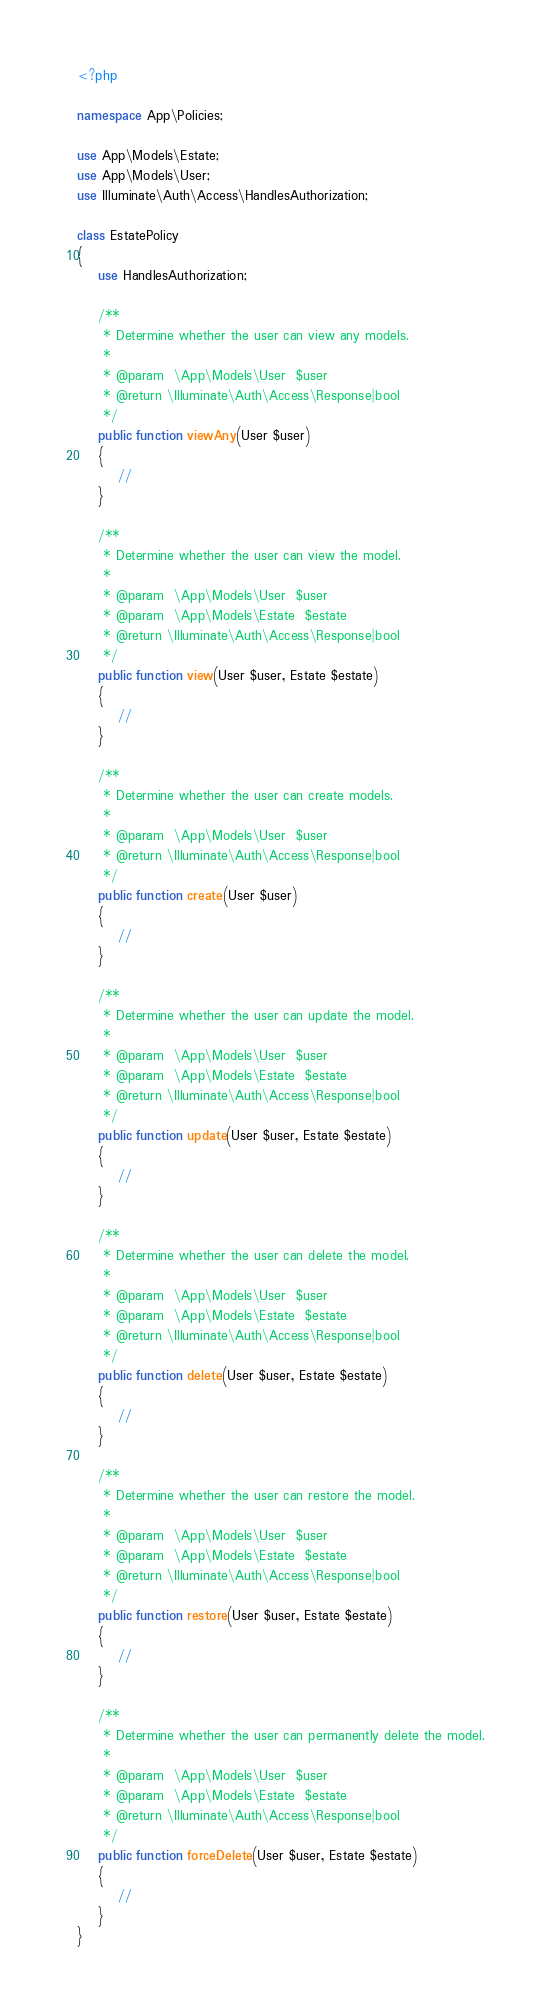<code> <loc_0><loc_0><loc_500><loc_500><_PHP_><?php

namespace App\Policies;

use App\Models\Estate;
use App\Models\User;
use Illuminate\Auth\Access\HandlesAuthorization;

class EstatePolicy
{
    use HandlesAuthorization;

    /**
     * Determine whether the user can view any models.
     *
     * @param  \App\Models\User  $user
     * @return \Illuminate\Auth\Access\Response|bool
     */
    public function viewAny(User $user)
    {
        //
    }

    /**
     * Determine whether the user can view the model.
     *
     * @param  \App\Models\User  $user
     * @param  \App\Models\Estate  $estate
     * @return \Illuminate\Auth\Access\Response|bool
     */
    public function view(User $user, Estate $estate)
    {
        //
    }

    /**
     * Determine whether the user can create models.
     *
     * @param  \App\Models\User  $user
     * @return \Illuminate\Auth\Access\Response|bool
     */
    public function create(User $user)
    {
        //
    }

    /**
     * Determine whether the user can update the model.
     *
     * @param  \App\Models\User  $user
     * @param  \App\Models\Estate  $estate
     * @return \Illuminate\Auth\Access\Response|bool
     */
    public function update(User $user, Estate $estate)
    {
        //
    }

    /**
     * Determine whether the user can delete the model.
     *
     * @param  \App\Models\User  $user
     * @param  \App\Models\Estate  $estate
     * @return \Illuminate\Auth\Access\Response|bool
     */
    public function delete(User $user, Estate $estate)
    {
        //
    }

    /**
     * Determine whether the user can restore the model.
     *
     * @param  \App\Models\User  $user
     * @param  \App\Models\Estate  $estate
     * @return \Illuminate\Auth\Access\Response|bool
     */
    public function restore(User $user, Estate $estate)
    {
        //
    }

    /**
     * Determine whether the user can permanently delete the model.
     *
     * @param  \App\Models\User  $user
     * @param  \App\Models\Estate  $estate
     * @return \Illuminate\Auth\Access\Response|bool
     */
    public function forceDelete(User $user, Estate $estate)
    {
        //
    }
}
</code> 